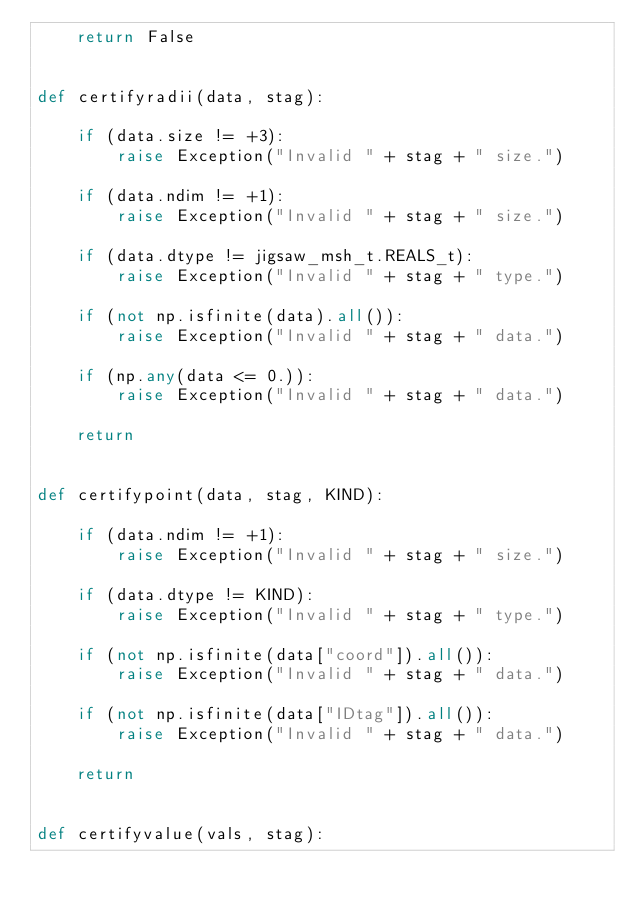<code> <loc_0><loc_0><loc_500><loc_500><_Python_>    return False


def certifyradii(data, stag):

    if (data.size != +3):
        raise Exception("Invalid " + stag + " size.")

    if (data.ndim != +1):
        raise Exception("Invalid " + stag + " size.")

    if (data.dtype != jigsaw_msh_t.REALS_t):
        raise Exception("Invalid " + stag + " type.")

    if (not np.isfinite(data).all()):
        raise Exception("Invalid " + stag + " data.")

    if (np.any(data <= 0.)):
        raise Exception("Invalid " + stag + " data.")

    return


def certifypoint(data, stag, KIND):

    if (data.ndim != +1):
        raise Exception("Invalid " + stag + " size.")

    if (data.dtype != KIND):
        raise Exception("Invalid " + stag + " type.")

    if (not np.isfinite(data["coord"]).all()):
        raise Exception("Invalid " + stag + " data.")

    if (not np.isfinite(data["IDtag"]).all()):
        raise Exception("Invalid " + stag + " data.")

    return


def certifyvalue(vals, stag):
</code> 